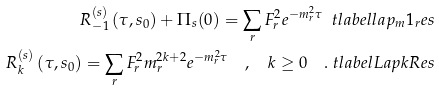Convert formula to latex. <formula><loc_0><loc_0><loc_500><loc_500>R ^ { ( s ) } _ { - 1 } \left ( \tau , s _ { 0 } \right ) + \Pi _ { s } ( 0 ) = \sum _ { r } F _ { r } ^ { 2 } e ^ { - m _ { r } ^ { 2 } \tau } \ t l a b e l { l a p _ { m } 1 _ { r } e s } \\ R ^ { ( s ) } _ { k } \left ( \tau , s _ { 0 } \right ) = \sum _ { r } F _ { r } ^ { 2 } m _ { r } ^ { 2 k + 2 } e ^ { - m _ { r } ^ { 2 } \tau } \quad , \quad k \geq 0 \quad . \ t l a b e l { L a p k R e s }</formula> 